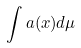<formula> <loc_0><loc_0><loc_500><loc_500>\int a ( x ) d \mu</formula> 